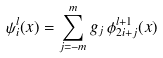<formula> <loc_0><loc_0><loc_500><loc_500>\psi _ { i } ^ { l } ( x ) = \sum _ { j = - m } ^ { m } g _ { j } \, \phi _ { 2 i + j } ^ { l + 1 } ( x )</formula> 